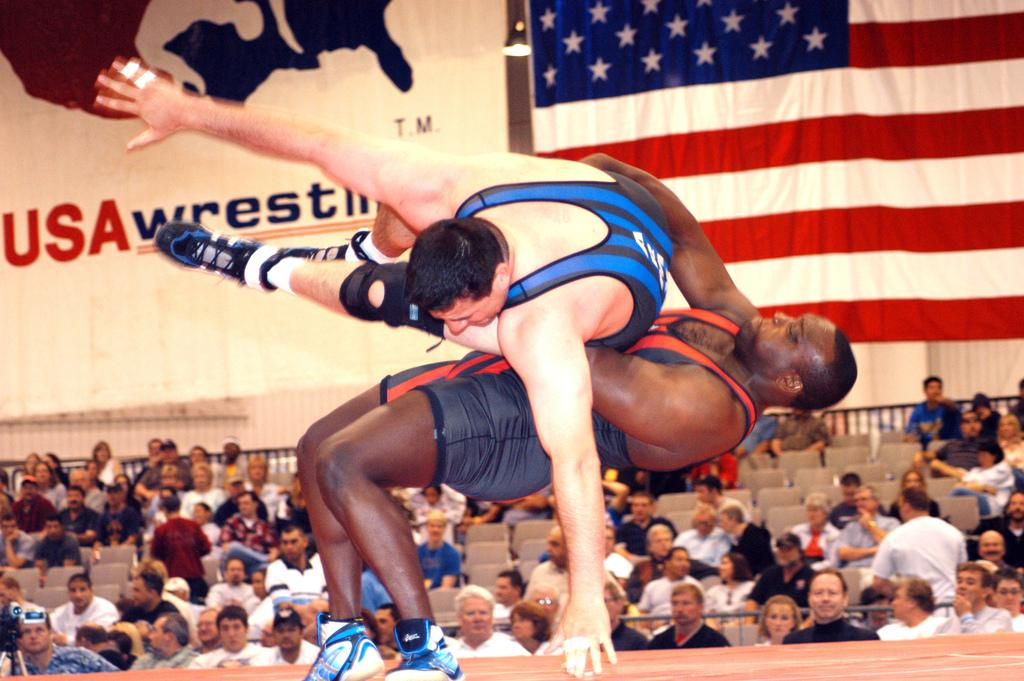Provide a one-sentence caption for the provided image. a person throwing another one down with usawrestling in the back. 